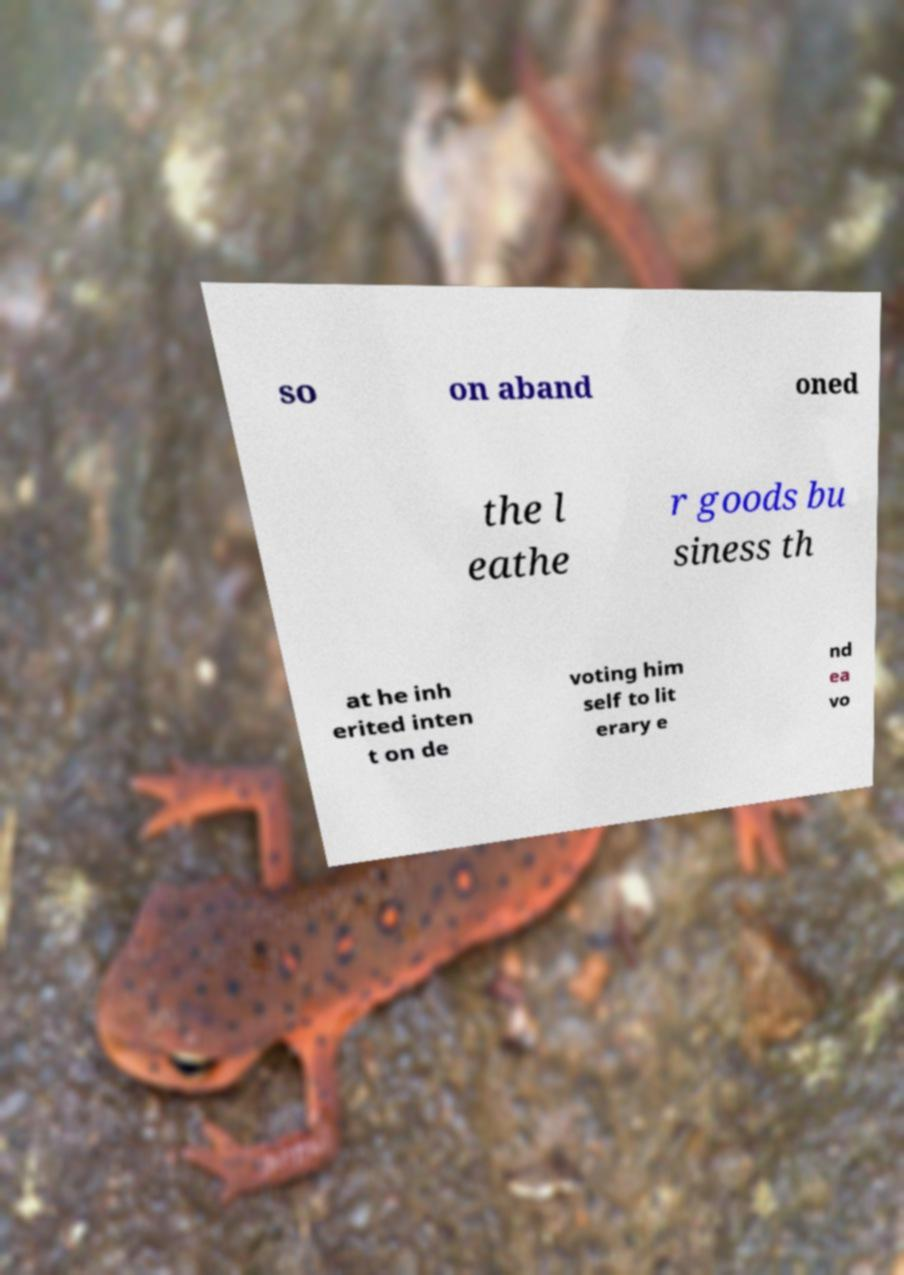Could you extract and type out the text from this image? so on aband oned the l eathe r goods bu siness th at he inh erited inten t on de voting him self to lit erary e nd ea vo 